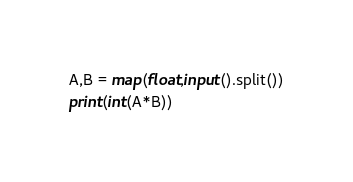Convert code to text. <code><loc_0><loc_0><loc_500><loc_500><_Python_>A,B = map(float,input().split())
print(int(A*B))
</code> 